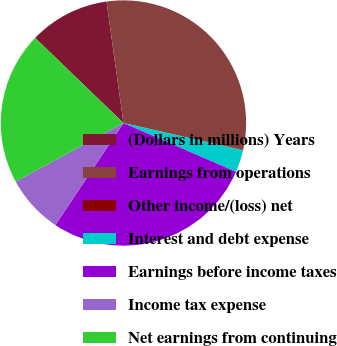Convert chart. <chart><loc_0><loc_0><loc_500><loc_500><pie_chart><fcel>(Dollars in millions) Years<fcel>Earnings from operations<fcel>Other income/(loss) net<fcel>Interest and debt expense<fcel>Earnings before income taxes<fcel>Income tax expense<fcel>Net earnings from continuing<nl><fcel>10.59%<fcel>30.73%<fcel>0.05%<fcel>2.94%<fcel>27.84%<fcel>7.7%<fcel>20.14%<nl></chart> 